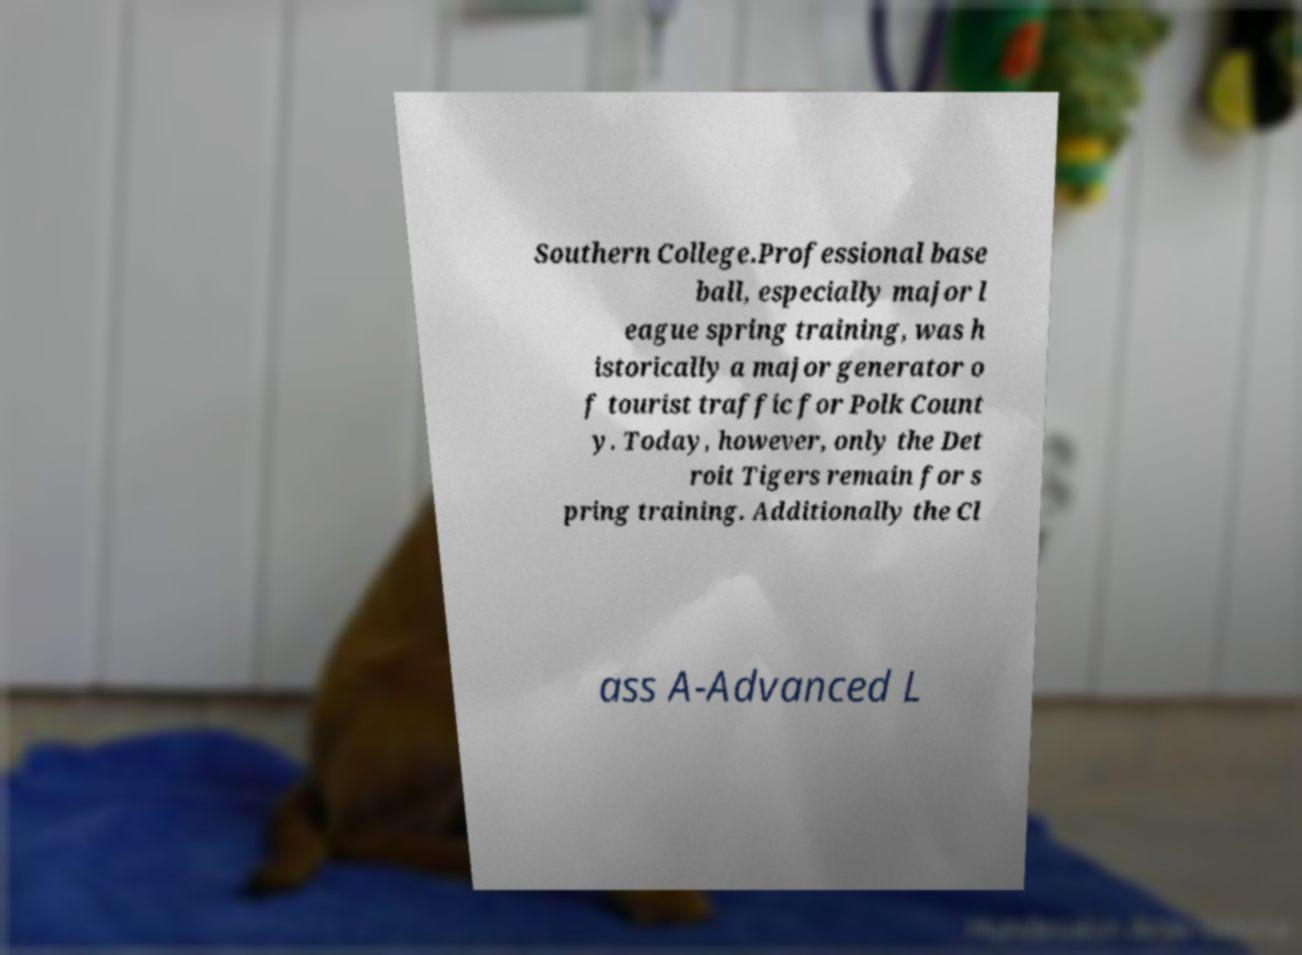Could you assist in decoding the text presented in this image and type it out clearly? Southern College.Professional base ball, especially major l eague spring training, was h istorically a major generator o f tourist traffic for Polk Count y. Today, however, only the Det roit Tigers remain for s pring training. Additionally the Cl ass A-Advanced L 